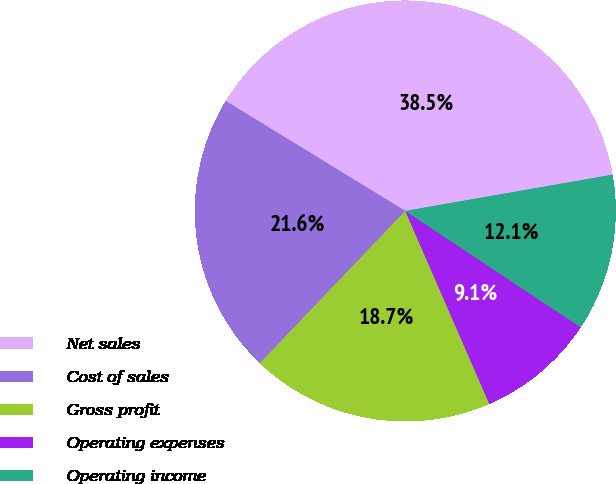<chart> <loc_0><loc_0><loc_500><loc_500><pie_chart><fcel>Net sales<fcel>Cost of sales<fcel>Gross profit<fcel>Operating expenses<fcel>Operating income<nl><fcel>38.5%<fcel>21.61%<fcel>18.67%<fcel>9.14%<fcel>12.08%<nl></chart> 